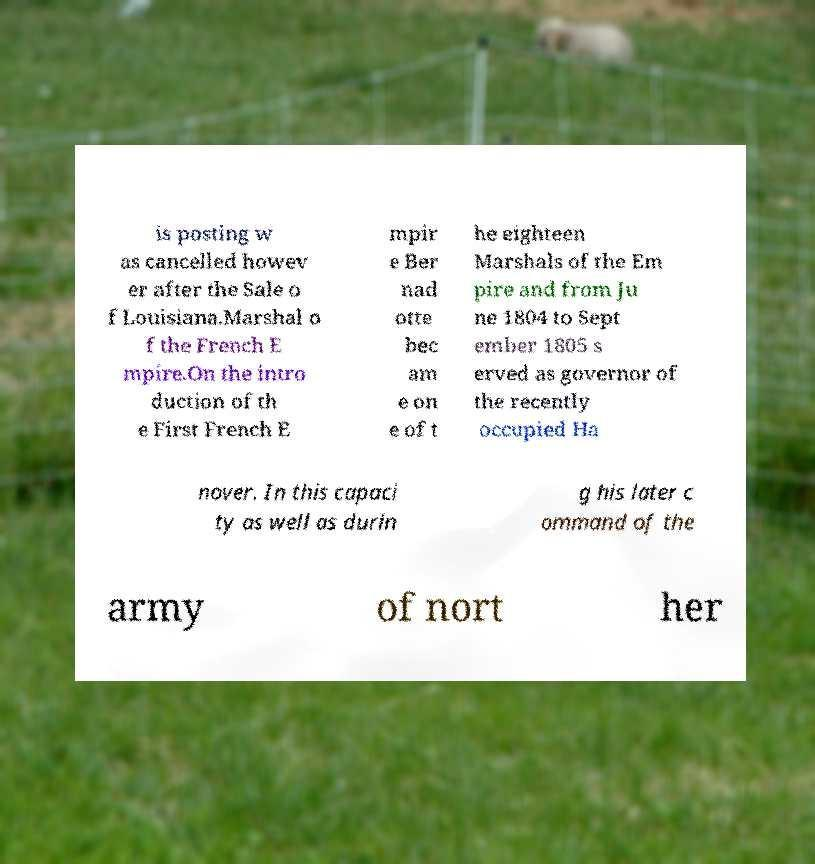Can you read and provide the text displayed in the image?This photo seems to have some interesting text. Can you extract and type it out for me? is posting w as cancelled howev er after the Sale o f Louisiana.Marshal o f the French E mpire.On the intro duction of th e First French E mpir e Ber nad otte bec am e on e of t he eighteen Marshals of the Em pire and from Ju ne 1804 to Sept ember 1805 s erved as governor of the recently occupied Ha nover. In this capaci ty as well as durin g his later c ommand of the army of nort her 